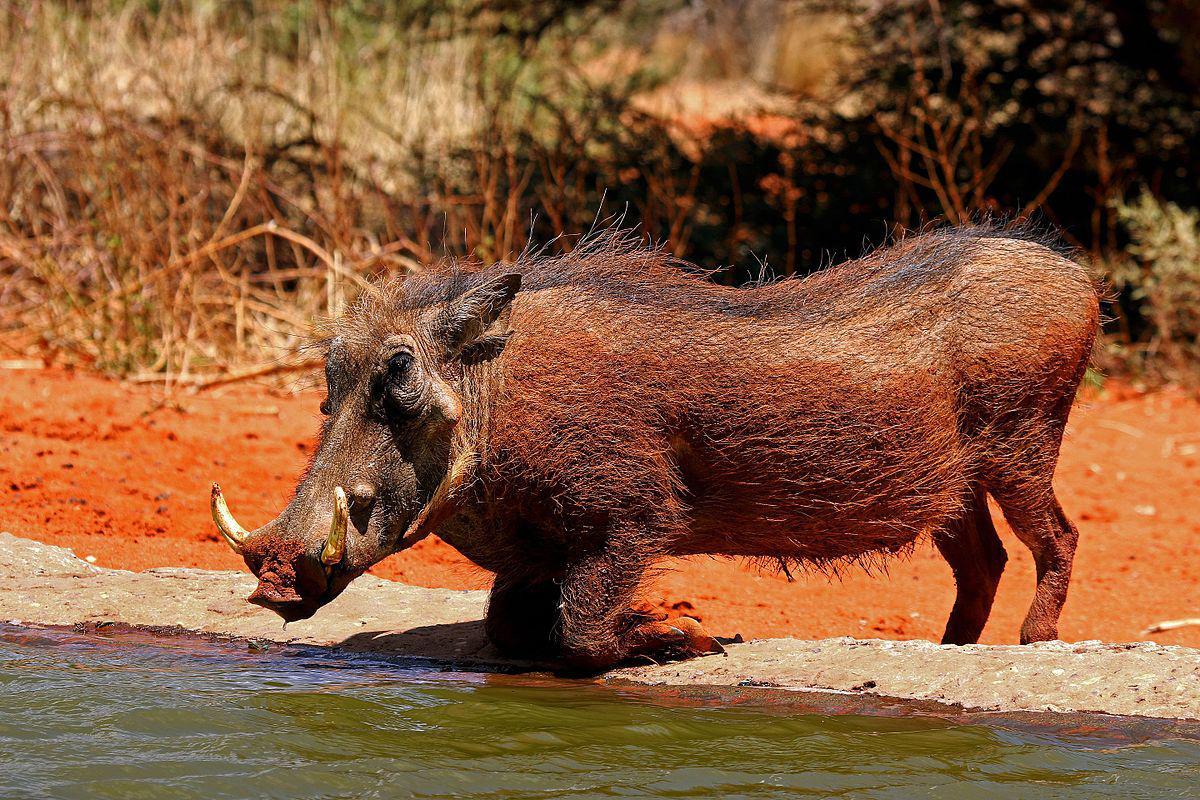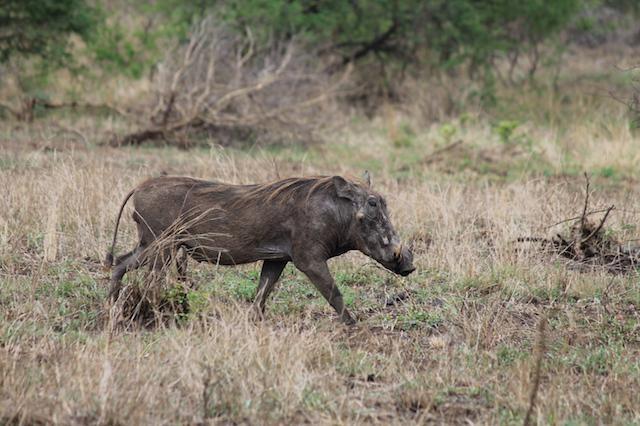The first image is the image on the left, the second image is the image on the right. Given the left and right images, does the statement "One of the images shows an animal in close proximity to water." hold true? Answer yes or no. Yes. The first image is the image on the left, the second image is the image on the right. Considering the images on both sides, is "All the animals appear in front of a completely green background." valid? Answer yes or no. No. 